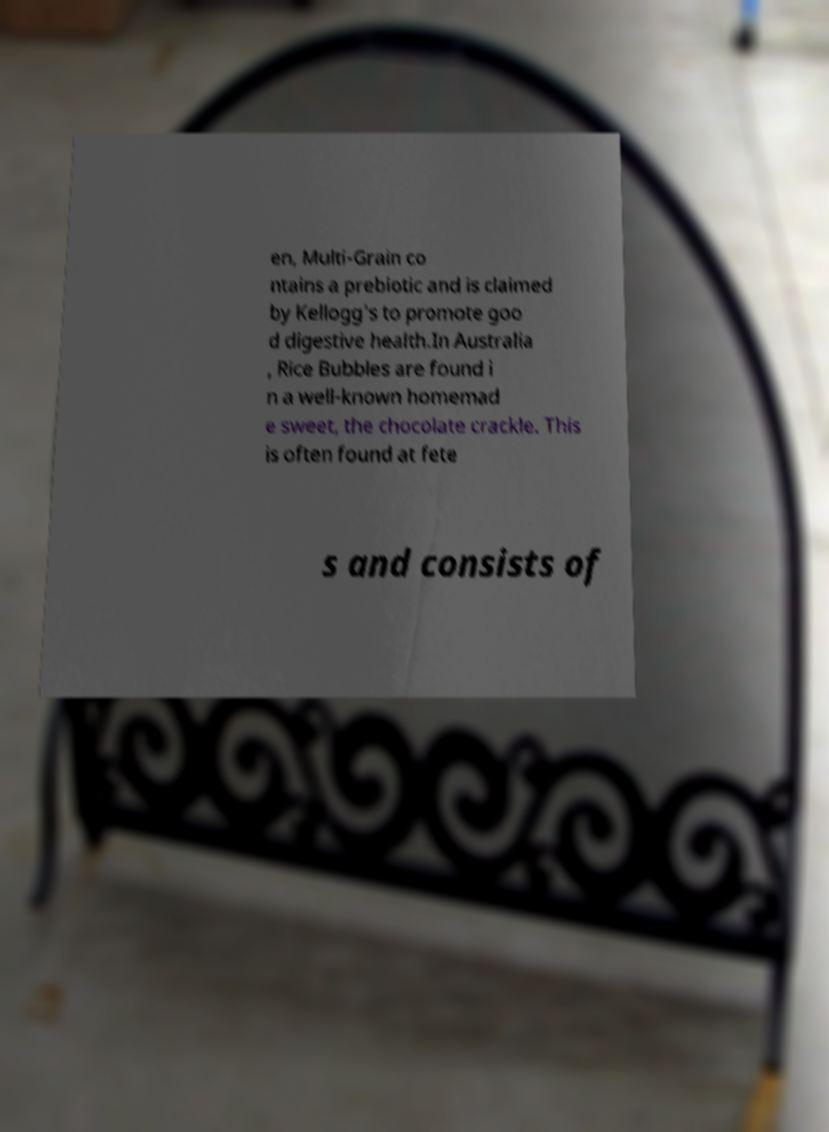For documentation purposes, I need the text within this image transcribed. Could you provide that? en, Multi-Grain co ntains a prebiotic and is claimed by Kellogg's to promote goo d digestive health.In Australia , Rice Bubbles are found i n a well-known homemad e sweet, the chocolate crackle. This is often found at fete s and consists of 